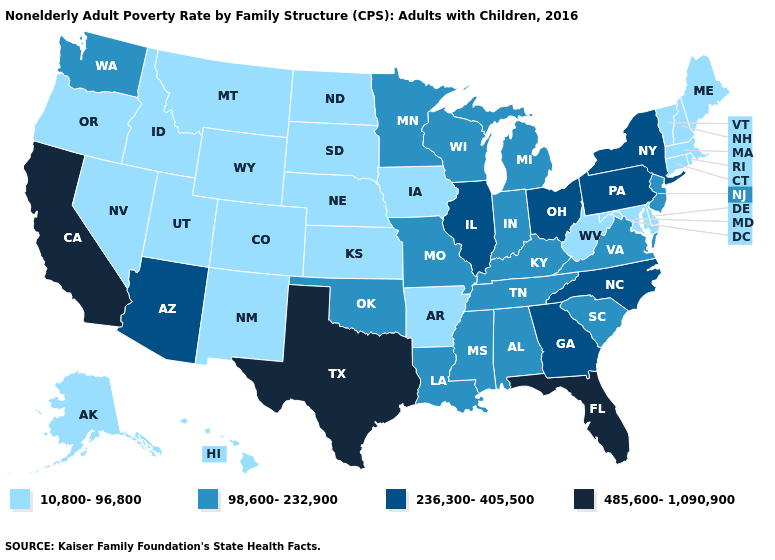What is the highest value in the USA?
Concise answer only. 485,600-1,090,900. How many symbols are there in the legend?
Be succinct. 4. Name the states that have a value in the range 98,600-232,900?
Write a very short answer. Alabama, Indiana, Kentucky, Louisiana, Michigan, Minnesota, Mississippi, Missouri, New Jersey, Oklahoma, South Carolina, Tennessee, Virginia, Washington, Wisconsin. What is the value of South Carolina?
Answer briefly. 98,600-232,900. What is the lowest value in states that border Florida?
Keep it brief. 98,600-232,900. What is the value of Kansas?
Give a very brief answer. 10,800-96,800. Among the states that border Rhode Island , which have the lowest value?
Give a very brief answer. Connecticut, Massachusetts. What is the value of Iowa?
Short answer required. 10,800-96,800. Which states have the lowest value in the West?
Give a very brief answer. Alaska, Colorado, Hawaii, Idaho, Montana, Nevada, New Mexico, Oregon, Utah, Wyoming. Does Alabama have a lower value than Florida?
Keep it brief. Yes. Among the states that border Wisconsin , does Minnesota have the highest value?
Short answer required. No. Name the states that have a value in the range 236,300-405,500?
Quick response, please. Arizona, Georgia, Illinois, New York, North Carolina, Ohio, Pennsylvania. What is the highest value in states that border Delaware?
Be succinct. 236,300-405,500. Does the first symbol in the legend represent the smallest category?
Concise answer only. Yes. Does the first symbol in the legend represent the smallest category?
Concise answer only. Yes. 